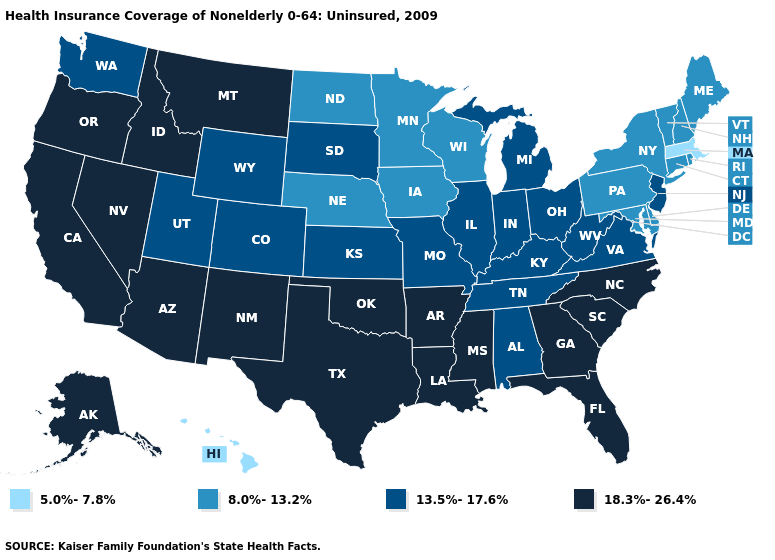Is the legend a continuous bar?
Give a very brief answer. No. Name the states that have a value in the range 13.5%-17.6%?
Write a very short answer. Alabama, Colorado, Illinois, Indiana, Kansas, Kentucky, Michigan, Missouri, New Jersey, Ohio, South Dakota, Tennessee, Utah, Virginia, Washington, West Virginia, Wyoming. Does Texas have the lowest value in the South?
Concise answer only. No. What is the value of Mississippi?
Write a very short answer. 18.3%-26.4%. Name the states that have a value in the range 18.3%-26.4%?
Answer briefly. Alaska, Arizona, Arkansas, California, Florida, Georgia, Idaho, Louisiana, Mississippi, Montana, Nevada, New Mexico, North Carolina, Oklahoma, Oregon, South Carolina, Texas. Name the states that have a value in the range 8.0%-13.2%?
Short answer required. Connecticut, Delaware, Iowa, Maine, Maryland, Minnesota, Nebraska, New Hampshire, New York, North Dakota, Pennsylvania, Rhode Island, Vermont, Wisconsin. What is the value of Indiana?
Keep it brief. 13.5%-17.6%. Name the states that have a value in the range 13.5%-17.6%?
Write a very short answer. Alabama, Colorado, Illinois, Indiana, Kansas, Kentucky, Michigan, Missouri, New Jersey, Ohio, South Dakota, Tennessee, Utah, Virginia, Washington, West Virginia, Wyoming. Name the states that have a value in the range 5.0%-7.8%?
Keep it brief. Hawaii, Massachusetts. Which states have the lowest value in the West?
Quick response, please. Hawaii. Does Oregon have the highest value in the West?
Write a very short answer. Yes. What is the lowest value in the South?
Write a very short answer. 8.0%-13.2%. What is the lowest value in states that border Rhode Island?
Answer briefly. 5.0%-7.8%. Name the states that have a value in the range 8.0%-13.2%?
Keep it brief. Connecticut, Delaware, Iowa, Maine, Maryland, Minnesota, Nebraska, New Hampshire, New York, North Dakota, Pennsylvania, Rhode Island, Vermont, Wisconsin. Does the map have missing data?
Give a very brief answer. No. 